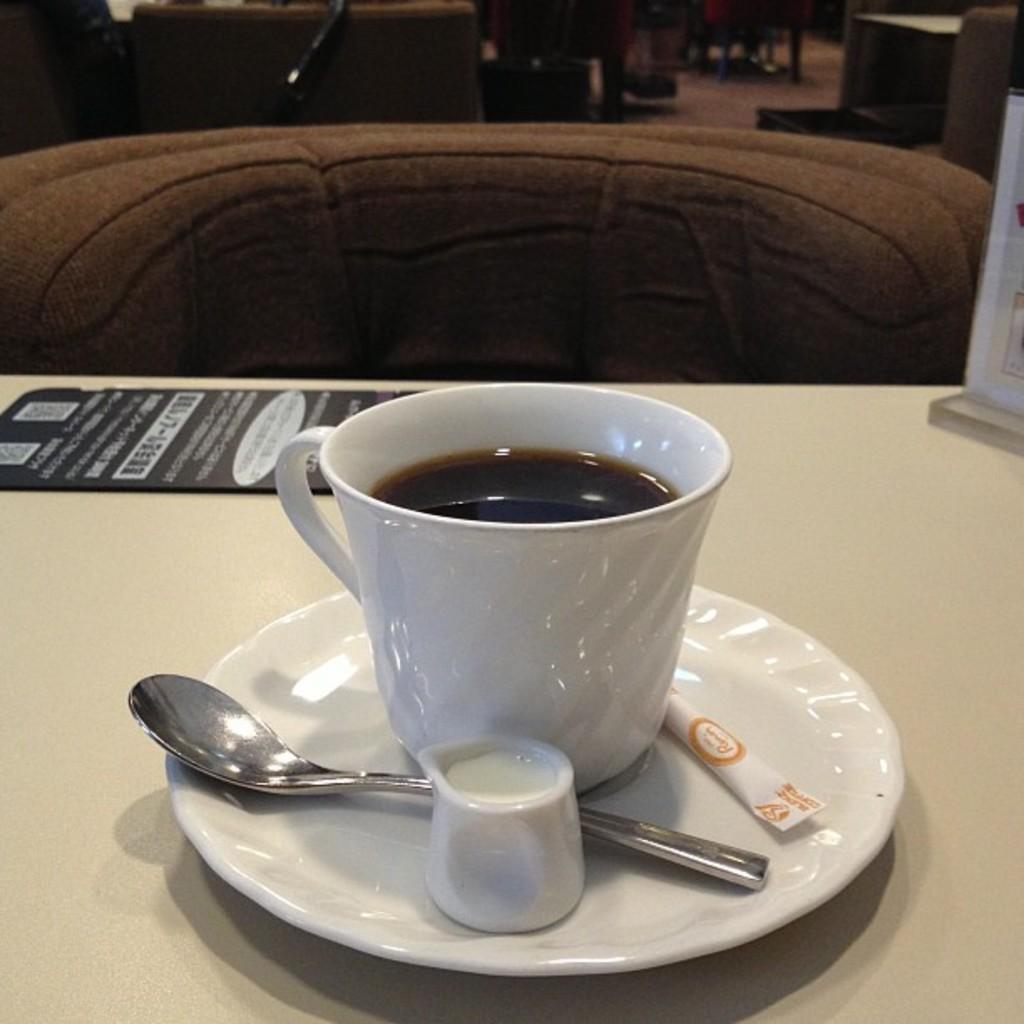Could you give a brief overview of what you see in this image? Here we can see a cup of coffee placed on a saucer and there is a spoon present and all of them are placed on a table and there is a pamphlet present here 